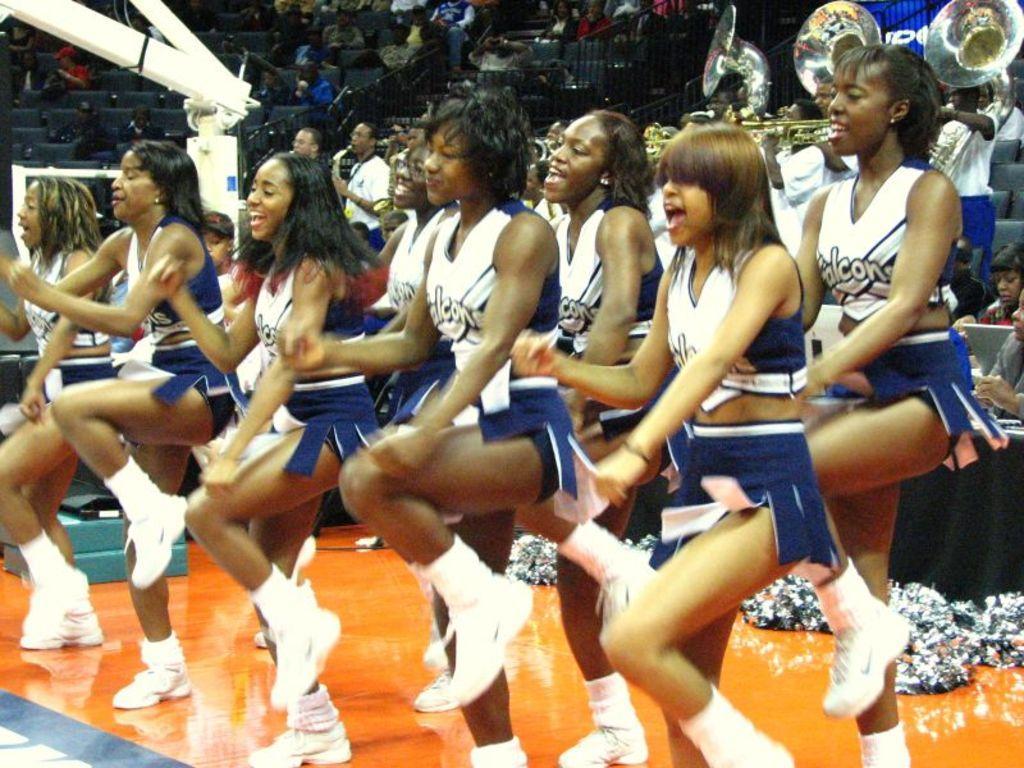Please provide a concise description of this image. In this picture we can see the group of persons were dancing. On the right we can see another group of persons were playing flute. On the left we can see a basketball court. In the background we can see the audience were sitting on the chair. 